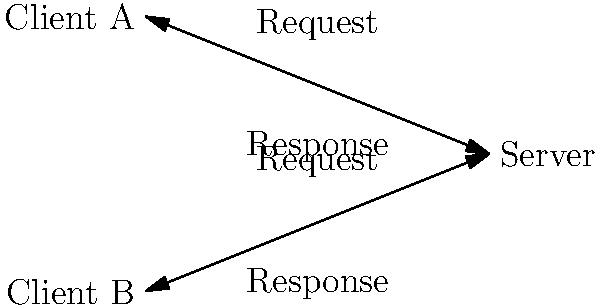In the basic client-server network model shown above, what is the primary role of the server in this interaction? To understand the role of the server in a client-server network model, let's break down the interaction:

1. Clients (A and B) initiate communication by sending requests to the server.
2. The server receives these requests from multiple clients.
3. Upon receiving a request, the server processes it. This may involve:
   - Retrieving data from a database
   - Performing computations
   - Accessing other resources
4. After processing, the server prepares a response for each client.
5. The server then sends these responses back to the respective clients.
6. This process can happen concurrently for multiple clients.

The key aspect here is that the server acts as a central point that:
- Listens for incoming requests
- Processes these requests
- Provides appropriate responses

This centralized model allows for efficient resource management and data consistency, as the server can control access to shared resources and ensure all clients receive consistent information.
Answer: To process requests and provide responses to multiple clients 